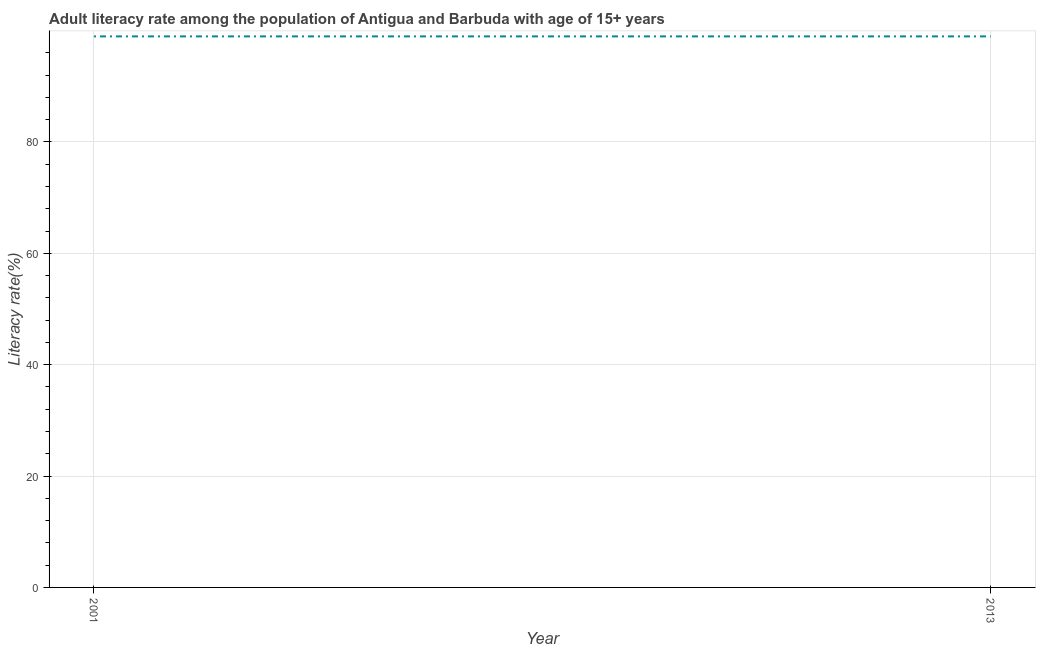What is the adult literacy rate in 2013?
Make the answer very short. 98.95. Across all years, what is the maximum adult literacy rate?
Provide a short and direct response. 98.95. Across all years, what is the minimum adult literacy rate?
Provide a short and direct response. 98.95. In which year was the adult literacy rate maximum?
Your response must be concise. 2001. What is the sum of the adult literacy rate?
Your answer should be compact. 197.9. What is the difference between the adult literacy rate in 2001 and 2013?
Your answer should be very brief. 0. What is the average adult literacy rate per year?
Provide a short and direct response. 98.95. What is the median adult literacy rate?
Ensure brevity in your answer.  98.95. What is the ratio of the adult literacy rate in 2001 to that in 2013?
Keep it short and to the point. 1. In how many years, is the adult literacy rate greater than the average adult literacy rate taken over all years?
Offer a terse response. 0. Does the adult literacy rate monotonically increase over the years?
Your response must be concise. No. How many lines are there?
Give a very brief answer. 1. How many years are there in the graph?
Your answer should be compact. 2. Are the values on the major ticks of Y-axis written in scientific E-notation?
Make the answer very short. No. Does the graph contain any zero values?
Provide a succinct answer. No. Does the graph contain grids?
Offer a terse response. Yes. What is the title of the graph?
Provide a succinct answer. Adult literacy rate among the population of Antigua and Barbuda with age of 15+ years. What is the label or title of the Y-axis?
Keep it short and to the point. Literacy rate(%). What is the Literacy rate(%) in 2001?
Offer a terse response. 98.95. What is the Literacy rate(%) of 2013?
Make the answer very short. 98.95. 